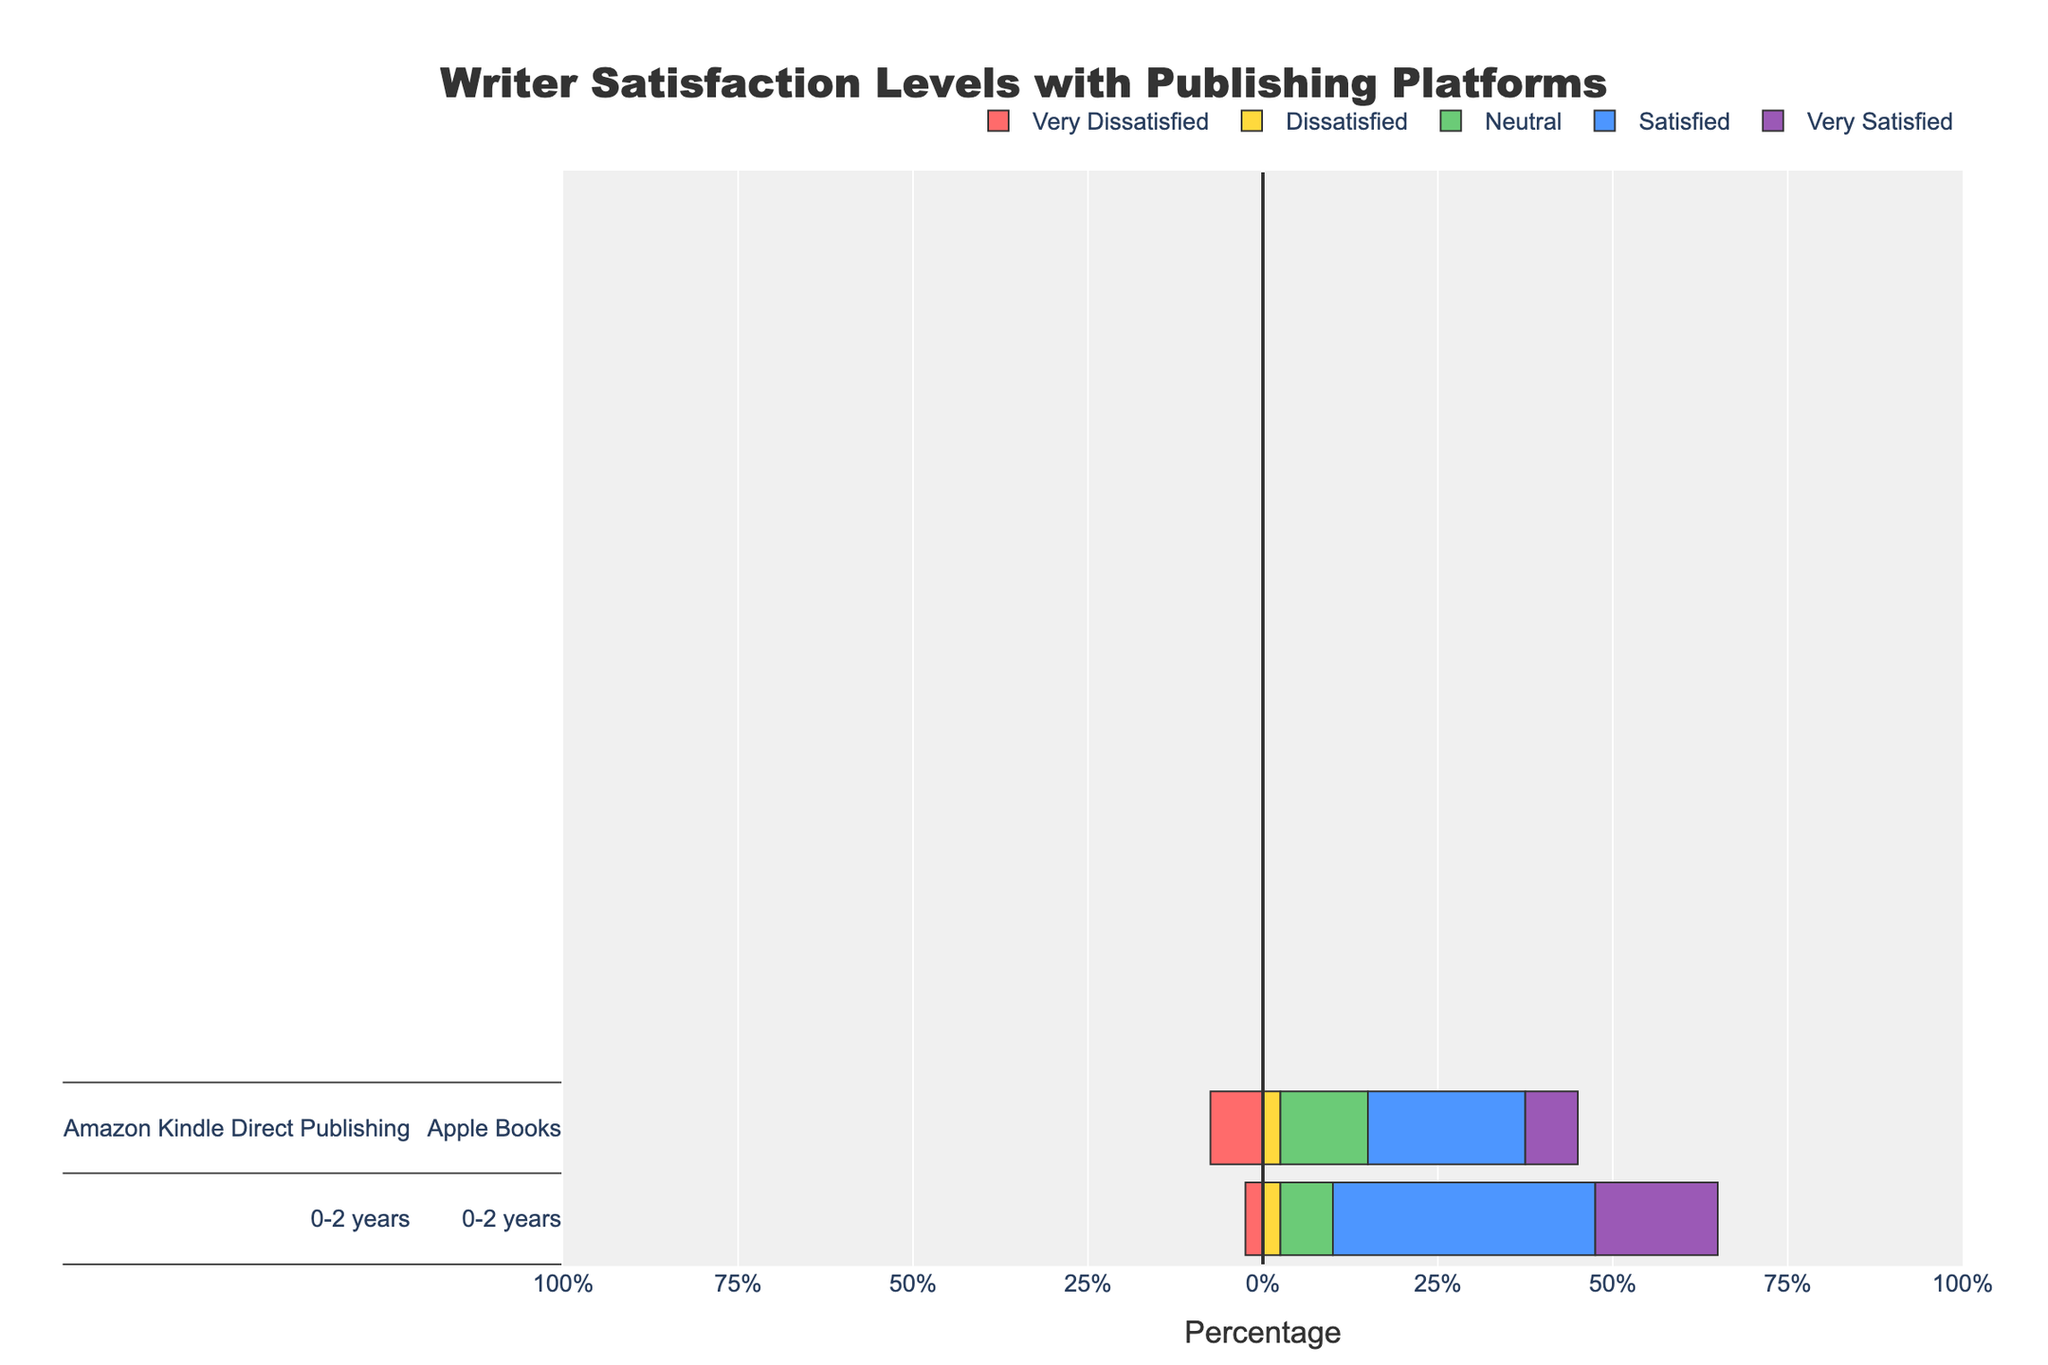What percentage of 3-5 years experienced writers are very satisfied with Amazon Kindle Direct Publishing? Look at the "3-5 years" category for Amazon Kindle Direct Publishing. The "Very Satisfied" level is represented with a certain color and has a value of 30%.
Answer: 30% Which publishing platform has the highest percentage of very satisfied writers with 6-10 years of experience? For the "6-10 years" category, compare the "Very Satisfied" percentages for Amazon Kindle Direct Publishing (35%), Apple Books (30%), and Barnes & Noble Press (25%).
Answer: Amazon Kindle Direct Publishing What is the combined percentage of satisfied and very satisfied writers with 0-2 years of experience on Apple Books? Add the percentages for "Satisfied" (35%) and "Very Satisfied" (20%) categories under the "0-2 years" experience section for Apple Books. The combined percentage is 35% + 20%.
Answer: 55% Which experience group has the least percentage of dissatisfied writers using Barnes & Noble Press? For each experience group (0-2, 3-5, 6-10, and 10+ years), determine the "Dissatisfied" percentages for Barnes & Noble Press. The values are 15%, 15%, 10%, and 10%, respectively. The least value is 10%.
Answer: 6-10 years, 10+ years What is the difference in the percentage of neutral satisfaction between 10+ years and 3-5 years experienced writers for Amazon Kindle Direct Publishing? Check the "Neutral" satisfaction levels for 10+ years and 3-5 years experienced writers for Amazon Kindle Direct Publishing. They are 10% and 10%, respectively. The difference is 0%.
Answer: 0% What is the average percentage of dissatisfied writers across all platforms for the 0-2 years experience group? Add the dissatisfied percentages of all publishing platforms (Amazon Kindle Direct Publishing: 10%, Apple Books: 15%, Barnes & Noble Press: 15%) and divide by the number of platforms (3). The average is (10% + 15% + 15%)/3.
Answer: 13.33% Which platform has the highest percentage of very dissatisfied writers across all experience levels? Compare the "Very Dissatisfied" percentages across all platforms and experience levels. Amazon Kindle Direct Publishing and Barnes & Noble Press have up to 10%, whereas Apple Books has a maximum of 5%.
Answer: Amazon Kindle Direct Publishing, Barnes & Noble Press What is the total percentage of writers who are either neutral or dissatisfied with Amazon Kindle Direct Publishing for all experience levels combined? Sum the percentages of "Neutral" and "Dissatisfied" satisfaction levels for Amazon Kindle Direct Publishing across all experience groups (0-2 years: 15% + 10%, 3-5 years: 10% + 15%, 6-10 years: 10% + 10%, 10+ years: 10% + 10%). The total is 25% + 25% + 20% + 20%.
Answer: 90% What is the highest percentage value among all satisfaction levels for writers with 6-10 years of experience across all platforms? Look at the satisfaction levels for 6-10 years experience across Amazon Kindle Direct Publishing, Apple Books, and Barnes & Noble Press. The highest value is found under "Satisfied" for Amazon Kindle Direct Publishing and Apple Books (both are 40%).
Answer: 40% 